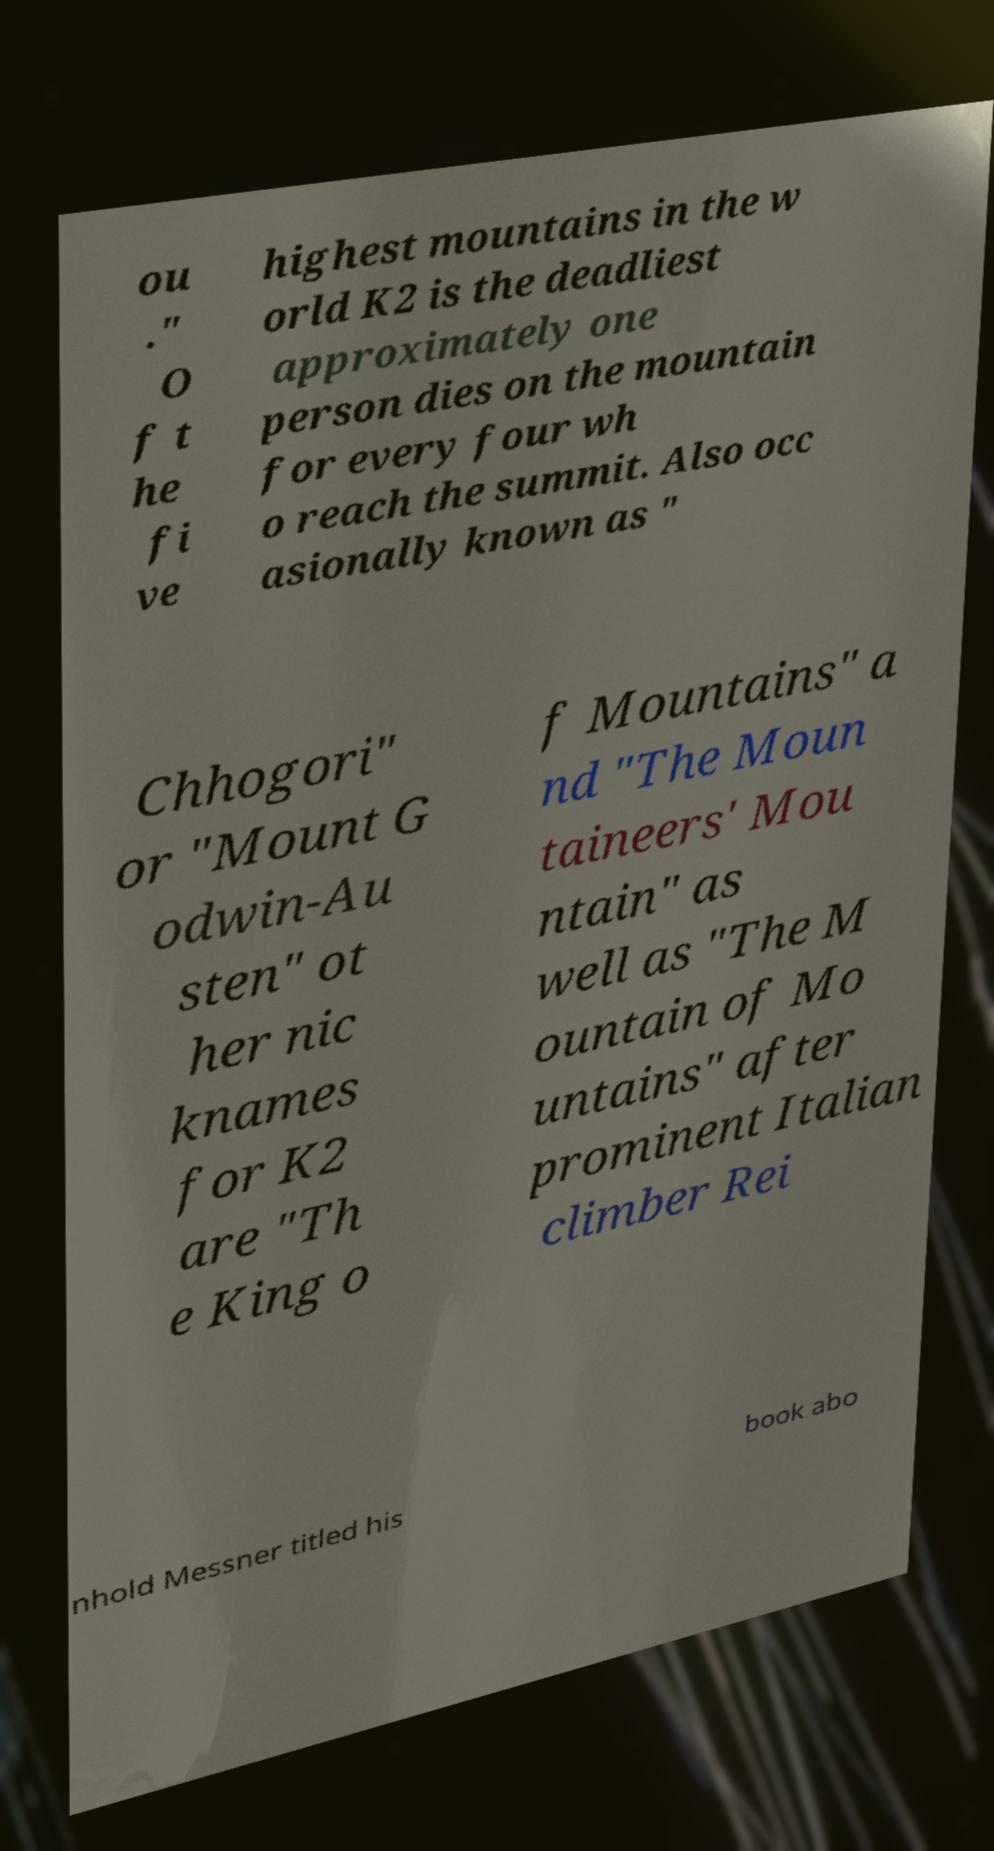Could you extract and type out the text from this image? ou ." O f t he fi ve highest mountains in the w orld K2 is the deadliest approximately one person dies on the mountain for every four wh o reach the summit. Also occ asionally known as " Chhogori" or "Mount G odwin-Au sten" ot her nic knames for K2 are "Th e King o f Mountains" a nd "The Moun taineers' Mou ntain" as well as "The M ountain of Mo untains" after prominent Italian climber Rei nhold Messner titled his book abo 